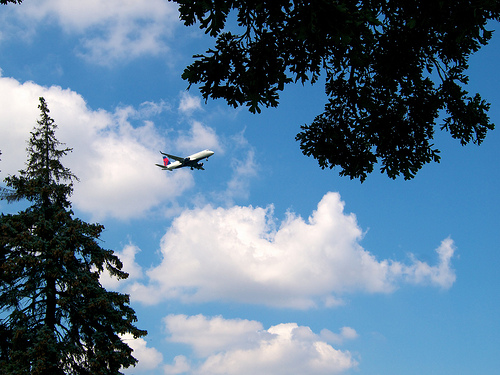How many planes are there? 1 